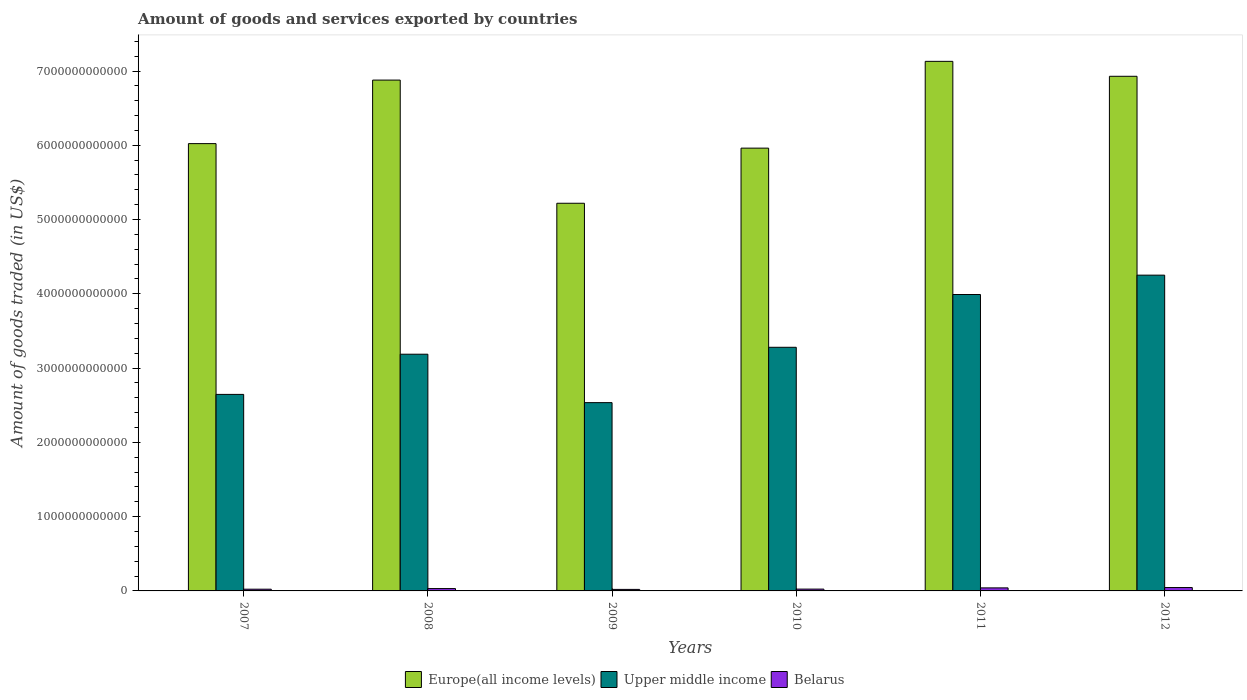How many groups of bars are there?
Provide a succinct answer. 6. In how many cases, is the number of bars for a given year not equal to the number of legend labels?
Your answer should be compact. 0. What is the total amount of goods and services exported in Belarus in 2011?
Your answer should be compact. 4.09e+1. Across all years, what is the maximum total amount of goods and services exported in Europe(all income levels)?
Your response must be concise. 7.13e+12. Across all years, what is the minimum total amount of goods and services exported in Upper middle income?
Your answer should be compact. 2.54e+12. In which year was the total amount of goods and services exported in Belarus maximum?
Provide a short and direct response. 2012. In which year was the total amount of goods and services exported in Belarus minimum?
Your answer should be compact. 2009. What is the total total amount of goods and services exported in Upper middle income in the graph?
Your response must be concise. 1.99e+13. What is the difference between the total amount of goods and services exported in Europe(all income levels) in 2007 and that in 2011?
Provide a short and direct response. -1.11e+12. What is the difference between the total amount of goods and services exported in Upper middle income in 2008 and the total amount of goods and services exported in Belarus in 2009?
Your response must be concise. 3.17e+12. What is the average total amount of goods and services exported in Belarus per year?
Provide a short and direct response. 3.11e+1. In the year 2010, what is the difference between the total amount of goods and services exported in Belarus and total amount of goods and services exported in Europe(all income levels)?
Your response must be concise. -5.94e+12. In how many years, is the total amount of goods and services exported in Upper middle income greater than 1000000000000 US$?
Keep it short and to the point. 6. What is the ratio of the total amount of goods and services exported in Europe(all income levels) in 2008 to that in 2010?
Your answer should be very brief. 1.15. Is the difference between the total amount of goods and services exported in Belarus in 2008 and 2010 greater than the difference between the total amount of goods and services exported in Europe(all income levels) in 2008 and 2010?
Provide a short and direct response. No. What is the difference between the highest and the second highest total amount of goods and services exported in Belarus?
Provide a short and direct response. 4.65e+09. What is the difference between the highest and the lowest total amount of goods and services exported in Europe(all income levels)?
Offer a very short reply. 1.91e+12. Is the sum of the total amount of goods and services exported in Upper middle income in 2008 and 2012 greater than the maximum total amount of goods and services exported in Belarus across all years?
Ensure brevity in your answer.  Yes. What does the 2nd bar from the left in 2007 represents?
Provide a succinct answer. Upper middle income. What does the 1st bar from the right in 2012 represents?
Your response must be concise. Belarus. How many bars are there?
Provide a short and direct response. 18. Are all the bars in the graph horizontal?
Your answer should be very brief. No. What is the difference between two consecutive major ticks on the Y-axis?
Provide a succinct answer. 1.00e+12. How many legend labels are there?
Your answer should be compact. 3. What is the title of the graph?
Your response must be concise. Amount of goods and services exported by countries. Does "New Zealand" appear as one of the legend labels in the graph?
Provide a succinct answer. No. What is the label or title of the X-axis?
Your answer should be very brief. Years. What is the label or title of the Y-axis?
Offer a terse response. Amount of goods traded (in US$). What is the Amount of goods traded (in US$) in Europe(all income levels) in 2007?
Your answer should be very brief. 6.02e+12. What is the Amount of goods traded (in US$) of Upper middle income in 2007?
Provide a short and direct response. 2.65e+12. What is the Amount of goods traded (in US$) of Belarus in 2007?
Provide a succinct answer. 2.33e+1. What is the Amount of goods traded (in US$) of Europe(all income levels) in 2008?
Your response must be concise. 6.88e+12. What is the Amount of goods traded (in US$) in Upper middle income in 2008?
Offer a terse response. 3.19e+12. What is the Amount of goods traded (in US$) in Belarus in 2008?
Offer a very short reply. 3.16e+1. What is the Amount of goods traded (in US$) of Europe(all income levels) in 2009?
Your response must be concise. 5.22e+12. What is the Amount of goods traded (in US$) of Upper middle income in 2009?
Give a very brief answer. 2.54e+12. What is the Amount of goods traded (in US$) of Belarus in 2009?
Provide a succinct answer. 2.06e+1. What is the Amount of goods traded (in US$) of Europe(all income levels) in 2010?
Give a very brief answer. 5.96e+12. What is the Amount of goods traded (in US$) of Upper middle income in 2010?
Keep it short and to the point. 3.28e+12. What is the Amount of goods traded (in US$) in Belarus in 2010?
Offer a terse response. 2.45e+1. What is the Amount of goods traded (in US$) of Europe(all income levels) in 2011?
Ensure brevity in your answer.  7.13e+12. What is the Amount of goods traded (in US$) of Upper middle income in 2011?
Your answer should be compact. 3.99e+12. What is the Amount of goods traded (in US$) in Belarus in 2011?
Keep it short and to the point. 4.09e+1. What is the Amount of goods traded (in US$) in Europe(all income levels) in 2012?
Your answer should be very brief. 6.93e+12. What is the Amount of goods traded (in US$) of Upper middle income in 2012?
Offer a very short reply. 4.25e+12. What is the Amount of goods traded (in US$) of Belarus in 2012?
Offer a very short reply. 4.56e+1. Across all years, what is the maximum Amount of goods traded (in US$) of Europe(all income levels)?
Offer a very short reply. 7.13e+12. Across all years, what is the maximum Amount of goods traded (in US$) of Upper middle income?
Offer a terse response. 4.25e+12. Across all years, what is the maximum Amount of goods traded (in US$) of Belarus?
Provide a short and direct response. 4.56e+1. Across all years, what is the minimum Amount of goods traded (in US$) in Europe(all income levels)?
Offer a very short reply. 5.22e+12. Across all years, what is the minimum Amount of goods traded (in US$) in Upper middle income?
Make the answer very short. 2.54e+12. Across all years, what is the minimum Amount of goods traded (in US$) in Belarus?
Offer a terse response. 2.06e+1. What is the total Amount of goods traded (in US$) of Europe(all income levels) in the graph?
Your response must be concise. 3.81e+13. What is the total Amount of goods traded (in US$) of Upper middle income in the graph?
Your answer should be compact. 1.99e+13. What is the total Amount of goods traded (in US$) of Belarus in the graph?
Provide a short and direct response. 1.87e+11. What is the difference between the Amount of goods traded (in US$) in Europe(all income levels) in 2007 and that in 2008?
Offer a terse response. -8.55e+11. What is the difference between the Amount of goods traded (in US$) of Upper middle income in 2007 and that in 2008?
Provide a short and direct response. -5.41e+11. What is the difference between the Amount of goods traded (in US$) in Belarus in 2007 and that in 2008?
Keep it short and to the point. -8.32e+09. What is the difference between the Amount of goods traded (in US$) of Europe(all income levels) in 2007 and that in 2009?
Your answer should be compact. 8.03e+11. What is the difference between the Amount of goods traded (in US$) in Upper middle income in 2007 and that in 2009?
Ensure brevity in your answer.  1.11e+11. What is the difference between the Amount of goods traded (in US$) of Belarus in 2007 and that in 2009?
Your response must be concise. 2.71e+09. What is the difference between the Amount of goods traded (in US$) of Europe(all income levels) in 2007 and that in 2010?
Your answer should be compact. 6.07e+1. What is the difference between the Amount of goods traded (in US$) in Upper middle income in 2007 and that in 2010?
Provide a short and direct response. -6.34e+11. What is the difference between the Amount of goods traded (in US$) of Belarus in 2007 and that in 2010?
Offer a very short reply. -1.20e+09. What is the difference between the Amount of goods traded (in US$) in Europe(all income levels) in 2007 and that in 2011?
Your answer should be very brief. -1.11e+12. What is the difference between the Amount of goods traded (in US$) in Upper middle income in 2007 and that in 2011?
Your answer should be compact. -1.34e+12. What is the difference between the Amount of goods traded (in US$) in Belarus in 2007 and that in 2011?
Give a very brief answer. -1.76e+1. What is the difference between the Amount of goods traded (in US$) of Europe(all income levels) in 2007 and that in 2012?
Make the answer very short. -9.07e+11. What is the difference between the Amount of goods traded (in US$) of Upper middle income in 2007 and that in 2012?
Your response must be concise. -1.61e+12. What is the difference between the Amount of goods traded (in US$) of Belarus in 2007 and that in 2012?
Provide a short and direct response. -2.23e+1. What is the difference between the Amount of goods traded (in US$) in Europe(all income levels) in 2008 and that in 2009?
Make the answer very short. 1.66e+12. What is the difference between the Amount of goods traded (in US$) in Upper middle income in 2008 and that in 2009?
Offer a very short reply. 6.52e+11. What is the difference between the Amount of goods traded (in US$) of Belarus in 2008 and that in 2009?
Your answer should be very brief. 1.10e+1. What is the difference between the Amount of goods traded (in US$) in Europe(all income levels) in 2008 and that in 2010?
Provide a succinct answer. 9.16e+11. What is the difference between the Amount of goods traded (in US$) of Upper middle income in 2008 and that in 2010?
Give a very brief answer. -9.30e+1. What is the difference between the Amount of goods traded (in US$) in Belarus in 2008 and that in 2010?
Your response must be concise. 7.12e+09. What is the difference between the Amount of goods traded (in US$) of Europe(all income levels) in 2008 and that in 2011?
Provide a succinct answer. -2.52e+11. What is the difference between the Amount of goods traded (in US$) of Upper middle income in 2008 and that in 2011?
Your answer should be very brief. -8.04e+11. What is the difference between the Amount of goods traded (in US$) in Belarus in 2008 and that in 2011?
Provide a succinct answer. -9.30e+09. What is the difference between the Amount of goods traded (in US$) in Europe(all income levels) in 2008 and that in 2012?
Provide a succinct answer. -5.12e+1. What is the difference between the Amount of goods traded (in US$) in Upper middle income in 2008 and that in 2012?
Provide a short and direct response. -1.06e+12. What is the difference between the Amount of goods traded (in US$) of Belarus in 2008 and that in 2012?
Provide a short and direct response. -1.39e+1. What is the difference between the Amount of goods traded (in US$) of Europe(all income levels) in 2009 and that in 2010?
Your answer should be very brief. -7.42e+11. What is the difference between the Amount of goods traded (in US$) of Upper middle income in 2009 and that in 2010?
Offer a terse response. -7.45e+11. What is the difference between the Amount of goods traded (in US$) in Belarus in 2009 and that in 2010?
Make the answer very short. -3.91e+09. What is the difference between the Amount of goods traded (in US$) in Europe(all income levels) in 2009 and that in 2011?
Your answer should be compact. -1.91e+12. What is the difference between the Amount of goods traded (in US$) of Upper middle income in 2009 and that in 2011?
Provide a succinct answer. -1.46e+12. What is the difference between the Amount of goods traded (in US$) of Belarus in 2009 and that in 2011?
Offer a terse response. -2.03e+1. What is the difference between the Amount of goods traded (in US$) of Europe(all income levels) in 2009 and that in 2012?
Keep it short and to the point. -1.71e+12. What is the difference between the Amount of goods traded (in US$) in Upper middle income in 2009 and that in 2012?
Ensure brevity in your answer.  -1.72e+12. What is the difference between the Amount of goods traded (in US$) of Belarus in 2009 and that in 2012?
Provide a short and direct response. -2.50e+1. What is the difference between the Amount of goods traded (in US$) in Europe(all income levels) in 2010 and that in 2011?
Your answer should be compact. -1.17e+12. What is the difference between the Amount of goods traded (in US$) in Upper middle income in 2010 and that in 2011?
Give a very brief answer. -7.11e+11. What is the difference between the Amount of goods traded (in US$) of Belarus in 2010 and that in 2011?
Give a very brief answer. -1.64e+1. What is the difference between the Amount of goods traded (in US$) in Europe(all income levels) in 2010 and that in 2012?
Offer a terse response. -9.67e+11. What is the difference between the Amount of goods traded (in US$) of Upper middle income in 2010 and that in 2012?
Make the answer very short. -9.71e+11. What is the difference between the Amount of goods traded (in US$) in Belarus in 2010 and that in 2012?
Provide a short and direct response. -2.11e+1. What is the difference between the Amount of goods traded (in US$) of Europe(all income levels) in 2011 and that in 2012?
Give a very brief answer. 2.01e+11. What is the difference between the Amount of goods traded (in US$) of Upper middle income in 2011 and that in 2012?
Offer a terse response. -2.61e+11. What is the difference between the Amount of goods traded (in US$) of Belarus in 2011 and that in 2012?
Your response must be concise. -4.65e+09. What is the difference between the Amount of goods traded (in US$) in Europe(all income levels) in 2007 and the Amount of goods traded (in US$) in Upper middle income in 2008?
Give a very brief answer. 2.84e+12. What is the difference between the Amount of goods traded (in US$) of Europe(all income levels) in 2007 and the Amount of goods traded (in US$) of Belarus in 2008?
Make the answer very short. 5.99e+12. What is the difference between the Amount of goods traded (in US$) in Upper middle income in 2007 and the Amount of goods traded (in US$) in Belarus in 2008?
Keep it short and to the point. 2.61e+12. What is the difference between the Amount of goods traded (in US$) of Europe(all income levels) in 2007 and the Amount of goods traded (in US$) of Upper middle income in 2009?
Make the answer very short. 3.49e+12. What is the difference between the Amount of goods traded (in US$) in Europe(all income levels) in 2007 and the Amount of goods traded (in US$) in Belarus in 2009?
Provide a short and direct response. 6.00e+12. What is the difference between the Amount of goods traded (in US$) of Upper middle income in 2007 and the Amount of goods traded (in US$) of Belarus in 2009?
Your answer should be very brief. 2.63e+12. What is the difference between the Amount of goods traded (in US$) in Europe(all income levels) in 2007 and the Amount of goods traded (in US$) in Upper middle income in 2010?
Give a very brief answer. 2.74e+12. What is the difference between the Amount of goods traded (in US$) in Europe(all income levels) in 2007 and the Amount of goods traded (in US$) in Belarus in 2010?
Provide a succinct answer. 6.00e+12. What is the difference between the Amount of goods traded (in US$) of Upper middle income in 2007 and the Amount of goods traded (in US$) of Belarus in 2010?
Provide a short and direct response. 2.62e+12. What is the difference between the Amount of goods traded (in US$) of Europe(all income levels) in 2007 and the Amount of goods traded (in US$) of Upper middle income in 2011?
Ensure brevity in your answer.  2.03e+12. What is the difference between the Amount of goods traded (in US$) of Europe(all income levels) in 2007 and the Amount of goods traded (in US$) of Belarus in 2011?
Provide a succinct answer. 5.98e+12. What is the difference between the Amount of goods traded (in US$) in Upper middle income in 2007 and the Amount of goods traded (in US$) in Belarus in 2011?
Give a very brief answer. 2.61e+12. What is the difference between the Amount of goods traded (in US$) in Europe(all income levels) in 2007 and the Amount of goods traded (in US$) in Upper middle income in 2012?
Offer a very short reply. 1.77e+12. What is the difference between the Amount of goods traded (in US$) of Europe(all income levels) in 2007 and the Amount of goods traded (in US$) of Belarus in 2012?
Provide a succinct answer. 5.98e+12. What is the difference between the Amount of goods traded (in US$) of Upper middle income in 2007 and the Amount of goods traded (in US$) of Belarus in 2012?
Offer a very short reply. 2.60e+12. What is the difference between the Amount of goods traded (in US$) in Europe(all income levels) in 2008 and the Amount of goods traded (in US$) in Upper middle income in 2009?
Ensure brevity in your answer.  4.34e+12. What is the difference between the Amount of goods traded (in US$) in Europe(all income levels) in 2008 and the Amount of goods traded (in US$) in Belarus in 2009?
Ensure brevity in your answer.  6.86e+12. What is the difference between the Amount of goods traded (in US$) in Upper middle income in 2008 and the Amount of goods traded (in US$) in Belarus in 2009?
Provide a short and direct response. 3.17e+12. What is the difference between the Amount of goods traded (in US$) in Europe(all income levels) in 2008 and the Amount of goods traded (in US$) in Upper middle income in 2010?
Provide a succinct answer. 3.60e+12. What is the difference between the Amount of goods traded (in US$) in Europe(all income levels) in 2008 and the Amount of goods traded (in US$) in Belarus in 2010?
Your answer should be compact. 6.85e+12. What is the difference between the Amount of goods traded (in US$) in Upper middle income in 2008 and the Amount of goods traded (in US$) in Belarus in 2010?
Offer a terse response. 3.16e+12. What is the difference between the Amount of goods traded (in US$) of Europe(all income levels) in 2008 and the Amount of goods traded (in US$) of Upper middle income in 2011?
Keep it short and to the point. 2.89e+12. What is the difference between the Amount of goods traded (in US$) of Europe(all income levels) in 2008 and the Amount of goods traded (in US$) of Belarus in 2011?
Provide a short and direct response. 6.84e+12. What is the difference between the Amount of goods traded (in US$) of Upper middle income in 2008 and the Amount of goods traded (in US$) of Belarus in 2011?
Your response must be concise. 3.15e+12. What is the difference between the Amount of goods traded (in US$) of Europe(all income levels) in 2008 and the Amount of goods traded (in US$) of Upper middle income in 2012?
Your response must be concise. 2.63e+12. What is the difference between the Amount of goods traded (in US$) in Europe(all income levels) in 2008 and the Amount of goods traded (in US$) in Belarus in 2012?
Your answer should be compact. 6.83e+12. What is the difference between the Amount of goods traded (in US$) of Upper middle income in 2008 and the Amount of goods traded (in US$) of Belarus in 2012?
Offer a very short reply. 3.14e+12. What is the difference between the Amount of goods traded (in US$) of Europe(all income levels) in 2009 and the Amount of goods traded (in US$) of Upper middle income in 2010?
Give a very brief answer. 1.94e+12. What is the difference between the Amount of goods traded (in US$) of Europe(all income levels) in 2009 and the Amount of goods traded (in US$) of Belarus in 2010?
Ensure brevity in your answer.  5.19e+12. What is the difference between the Amount of goods traded (in US$) in Upper middle income in 2009 and the Amount of goods traded (in US$) in Belarus in 2010?
Your response must be concise. 2.51e+12. What is the difference between the Amount of goods traded (in US$) of Europe(all income levels) in 2009 and the Amount of goods traded (in US$) of Upper middle income in 2011?
Offer a very short reply. 1.23e+12. What is the difference between the Amount of goods traded (in US$) in Europe(all income levels) in 2009 and the Amount of goods traded (in US$) in Belarus in 2011?
Ensure brevity in your answer.  5.18e+12. What is the difference between the Amount of goods traded (in US$) of Upper middle income in 2009 and the Amount of goods traded (in US$) of Belarus in 2011?
Make the answer very short. 2.49e+12. What is the difference between the Amount of goods traded (in US$) in Europe(all income levels) in 2009 and the Amount of goods traded (in US$) in Upper middle income in 2012?
Your answer should be compact. 9.68e+11. What is the difference between the Amount of goods traded (in US$) in Europe(all income levels) in 2009 and the Amount of goods traded (in US$) in Belarus in 2012?
Your answer should be very brief. 5.17e+12. What is the difference between the Amount of goods traded (in US$) in Upper middle income in 2009 and the Amount of goods traded (in US$) in Belarus in 2012?
Your answer should be compact. 2.49e+12. What is the difference between the Amount of goods traded (in US$) of Europe(all income levels) in 2010 and the Amount of goods traded (in US$) of Upper middle income in 2011?
Provide a succinct answer. 1.97e+12. What is the difference between the Amount of goods traded (in US$) of Europe(all income levels) in 2010 and the Amount of goods traded (in US$) of Belarus in 2011?
Your answer should be compact. 5.92e+12. What is the difference between the Amount of goods traded (in US$) in Upper middle income in 2010 and the Amount of goods traded (in US$) in Belarus in 2011?
Ensure brevity in your answer.  3.24e+12. What is the difference between the Amount of goods traded (in US$) in Europe(all income levels) in 2010 and the Amount of goods traded (in US$) in Upper middle income in 2012?
Your answer should be very brief. 1.71e+12. What is the difference between the Amount of goods traded (in US$) of Europe(all income levels) in 2010 and the Amount of goods traded (in US$) of Belarus in 2012?
Provide a succinct answer. 5.92e+12. What is the difference between the Amount of goods traded (in US$) in Upper middle income in 2010 and the Amount of goods traded (in US$) in Belarus in 2012?
Your answer should be very brief. 3.23e+12. What is the difference between the Amount of goods traded (in US$) in Europe(all income levels) in 2011 and the Amount of goods traded (in US$) in Upper middle income in 2012?
Your response must be concise. 2.88e+12. What is the difference between the Amount of goods traded (in US$) in Europe(all income levels) in 2011 and the Amount of goods traded (in US$) in Belarus in 2012?
Make the answer very short. 7.08e+12. What is the difference between the Amount of goods traded (in US$) in Upper middle income in 2011 and the Amount of goods traded (in US$) in Belarus in 2012?
Keep it short and to the point. 3.95e+12. What is the average Amount of goods traded (in US$) in Europe(all income levels) per year?
Your answer should be very brief. 6.36e+12. What is the average Amount of goods traded (in US$) in Upper middle income per year?
Offer a terse response. 3.32e+12. What is the average Amount of goods traded (in US$) of Belarus per year?
Your answer should be very brief. 3.11e+1. In the year 2007, what is the difference between the Amount of goods traded (in US$) in Europe(all income levels) and Amount of goods traded (in US$) in Upper middle income?
Provide a succinct answer. 3.38e+12. In the year 2007, what is the difference between the Amount of goods traded (in US$) in Europe(all income levels) and Amount of goods traded (in US$) in Belarus?
Give a very brief answer. 6.00e+12. In the year 2007, what is the difference between the Amount of goods traded (in US$) of Upper middle income and Amount of goods traded (in US$) of Belarus?
Make the answer very short. 2.62e+12. In the year 2008, what is the difference between the Amount of goods traded (in US$) in Europe(all income levels) and Amount of goods traded (in US$) in Upper middle income?
Your answer should be compact. 3.69e+12. In the year 2008, what is the difference between the Amount of goods traded (in US$) of Europe(all income levels) and Amount of goods traded (in US$) of Belarus?
Give a very brief answer. 6.85e+12. In the year 2008, what is the difference between the Amount of goods traded (in US$) in Upper middle income and Amount of goods traded (in US$) in Belarus?
Your answer should be compact. 3.16e+12. In the year 2009, what is the difference between the Amount of goods traded (in US$) of Europe(all income levels) and Amount of goods traded (in US$) of Upper middle income?
Ensure brevity in your answer.  2.68e+12. In the year 2009, what is the difference between the Amount of goods traded (in US$) of Europe(all income levels) and Amount of goods traded (in US$) of Belarus?
Ensure brevity in your answer.  5.20e+12. In the year 2009, what is the difference between the Amount of goods traded (in US$) in Upper middle income and Amount of goods traded (in US$) in Belarus?
Make the answer very short. 2.51e+12. In the year 2010, what is the difference between the Amount of goods traded (in US$) in Europe(all income levels) and Amount of goods traded (in US$) in Upper middle income?
Make the answer very short. 2.68e+12. In the year 2010, what is the difference between the Amount of goods traded (in US$) in Europe(all income levels) and Amount of goods traded (in US$) in Belarus?
Your answer should be compact. 5.94e+12. In the year 2010, what is the difference between the Amount of goods traded (in US$) of Upper middle income and Amount of goods traded (in US$) of Belarus?
Your response must be concise. 3.26e+12. In the year 2011, what is the difference between the Amount of goods traded (in US$) in Europe(all income levels) and Amount of goods traded (in US$) in Upper middle income?
Keep it short and to the point. 3.14e+12. In the year 2011, what is the difference between the Amount of goods traded (in US$) of Europe(all income levels) and Amount of goods traded (in US$) of Belarus?
Your answer should be very brief. 7.09e+12. In the year 2011, what is the difference between the Amount of goods traded (in US$) of Upper middle income and Amount of goods traded (in US$) of Belarus?
Keep it short and to the point. 3.95e+12. In the year 2012, what is the difference between the Amount of goods traded (in US$) of Europe(all income levels) and Amount of goods traded (in US$) of Upper middle income?
Keep it short and to the point. 2.68e+12. In the year 2012, what is the difference between the Amount of goods traded (in US$) in Europe(all income levels) and Amount of goods traded (in US$) in Belarus?
Offer a very short reply. 6.88e+12. In the year 2012, what is the difference between the Amount of goods traded (in US$) in Upper middle income and Amount of goods traded (in US$) in Belarus?
Your response must be concise. 4.21e+12. What is the ratio of the Amount of goods traded (in US$) of Europe(all income levels) in 2007 to that in 2008?
Ensure brevity in your answer.  0.88. What is the ratio of the Amount of goods traded (in US$) of Upper middle income in 2007 to that in 2008?
Make the answer very short. 0.83. What is the ratio of the Amount of goods traded (in US$) in Belarus in 2007 to that in 2008?
Provide a succinct answer. 0.74. What is the ratio of the Amount of goods traded (in US$) of Europe(all income levels) in 2007 to that in 2009?
Provide a short and direct response. 1.15. What is the ratio of the Amount of goods traded (in US$) of Upper middle income in 2007 to that in 2009?
Give a very brief answer. 1.04. What is the ratio of the Amount of goods traded (in US$) in Belarus in 2007 to that in 2009?
Your answer should be compact. 1.13. What is the ratio of the Amount of goods traded (in US$) in Europe(all income levels) in 2007 to that in 2010?
Ensure brevity in your answer.  1.01. What is the ratio of the Amount of goods traded (in US$) of Upper middle income in 2007 to that in 2010?
Make the answer very short. 0.81. What is the ratio of the Amount of goods traded (in US$) of Belarus in 2007 to that in 2010?
Give a very brief answer. 0.95. What is the ratio of the Amount of goods traded (in US$) of Europe(all income levels) in 2007 to that in 2011?
Your response must be concise. 0.84. What is the ratio of the Amount of goods traded (in US$) in Upper middle income in 2007 to that in 2011?
Your response must be concise. 0.66. What is the ratio of the Amount of goods traded (in US$) in Belarus in 2007 to that in 2011?
Ensure brevity in your answer.  0.57. What is the ratio of the Amount of goods traded (in US$) in Europe(all income levels) in 2007 to that in 2012?
Make the answer very short. 0.87. What is the ratio of the Amount of goods traded (in US$) of Upper middle income in 2007 to that in 2012?
Give a very brief answer. 0.62. What is the ratio of the Amount of goods traded (in US$) in Belarus in 2007 to that in 2012?
Provide a succinct answer. 0.51. What is the ratio of the Amount of goods traded (in US$) of Europe(all income levels) in 2008 to that in 2009?
Your answer should be very brief. 1.32. What is the ratio of the Amount of goods traded (in US$) of Upper middle income in 2008 to that in 2009?
Your response must be concise. 1.26. What is the ratio of the Amount of goods traded (in US$) of Belarus in 2008 to that in 2009?
Your response must be concise. 1.54. What is the ratio of the Amount of goods traded (in US$) of Europe(all income levels) in 2008 to that in 2010?
Offer a terse response. 1.15. What is the ratio of the Amount of goods traded (in US$) of Upper middle income in 2008 to that in 2010?
Keep it short and to the point. 0.97. What is the ratio of the Amount of goods traded (in US$) in Belarus in 2008 to that in 2010?
Your answer should be very brief. 1.29. What is the ratio of the Amount of goods traded (in US$) in Europe(all income levels) in 2008 to that in 2011?
Your answer should be compact. 0.96. What is the ratio of the Amount of goods traded (in US$) of Upper middle income in 2008 to that in 2011?
Your response must be concise. 0.8. What is the ratio of the Amount of goods traded (in US$) in Belarus in 2008 to that in 2011?
Your answer should be very brief. 0.77. What is the ratio of the Amount of goods traded (in US$) of Europe(all income levels) in 2008 to that in 2012?
Provide a short and direct response. 0.99. What is the ratio of the Amount of goods traded (in US$) of Upper middle income in 2008 to that in 2012?
Your response must be concise. 0.75. What is the ratio of the Amount of goods traded (in US$) in Belarus in 2008 to that in 2012?
Ensure brevity in your answer.  0.69. What is the ratio of the Amount of goods traded (in US$) of Europe(all income levels) in 2009 to that in 2010?
Give a very brief answer. 0.88. What is the ratio of the Amount of goods traded (in US$) of Upper middle income in 2009 to that in 2010?
Offer a very short reply. 0.77. What is the ratio of the Amount of goods traded (in US$) of Belarus in 2009 to that in 2010?
Give a very brief answer. 0.84. What is the ratio of the Amount of goods traded (in US$) in Europe(all income levels) in 2009 to that in 2011?
Give a very brief answer. 0.73. What is the ratio of the Amount of goods traded (in US$) of Upper middle income in 2009 to that in 2011?
Your answer should be very brief. 0.64. What is the ratio of the Amount of goods traded (in US$) in Belarus in 2009 to that in 2011?
Offer a terse response. 0.5. What is the ratio of the Amount of goods traded (in US$) in Europe(all income levels) in 2009 to that in 2012?
Ensure brevity in your answer.  0.75. What is the ratio of the Amount of goods traded (in US$) of Upper middle income in 2009 to that in 2012?
Your response must be concise. 0.6. What is the ratio of the Amount of goods traded (in US$) in Belarus in 2009 to that in 2012?
Your answer should be very brief. 0.45. What is the ratio of the Amount of goods traded (in US$) of Europe(all income levels) in 2010 to that in 2011?
Provide a succinct answer. 0.84. What is the ratio of the Amount of goods traded (in US$) in Upper middle income in 2010 to that in 2011?
Provide a short and direct response. 0.82. What is the ratio of the Amount of goods traded (in US$) in Belarus in 2010 to that in 2011?
Provide a succinct answer. 0.6. What is the ratio of the Amount of goods traded (in US$) of Europe(all income levels) in 2010 to that in 2012?
Keep it short and to the point. 0.86. What is the ratio of the Amount of goods traded (in US$) in Upper middle income in 2010 to that in 2012?
Provide a succinct answer. 0.77. What is the ratio of the Amount of goods traded (in US$) in Belarus in 2010 to that in 2012?
Your answer should be compact. 0.54. What is the ratio of the Amount of goods traded (in US$) in Upper middle income in 2011 to that in 2012?
Keep it short and to the point. 0.94. What is the ratio of the Amount of goods traded (in US$) in Belarus in 2011 to that in 2012?
Offer a terse response. 0.9. What is the difference between the highest and the second highest Amount of goods traded (in US$) in Europe(all income levels)?
Your answer should be very brief. 2.01e+11. What is the difference between the highest and the second highest Amount of goods traded (in US$) of Upper middle income?
Ensure brevity in your answer.  2.61e+11. What is the difference between the highest and the second highest Amount of goods traded (in US$) of Belarus?
Keep it short and to the point. 4.65e+09. What is the difference between the highest and the lowest Amount of goods traded (in US$) in Europe(all income levels)?
Offer a terse response. 1.91e+12. What is the difference between the highest and the lowest Amount of goods traded (in US$) of Upper middle income?
Keep it short and to the point. 1.72e+12. What is the difference between the highest and the lowest Amount of goods traded (in US$) of Belarus?
Provide a succinct answer. 2.50e+1. 